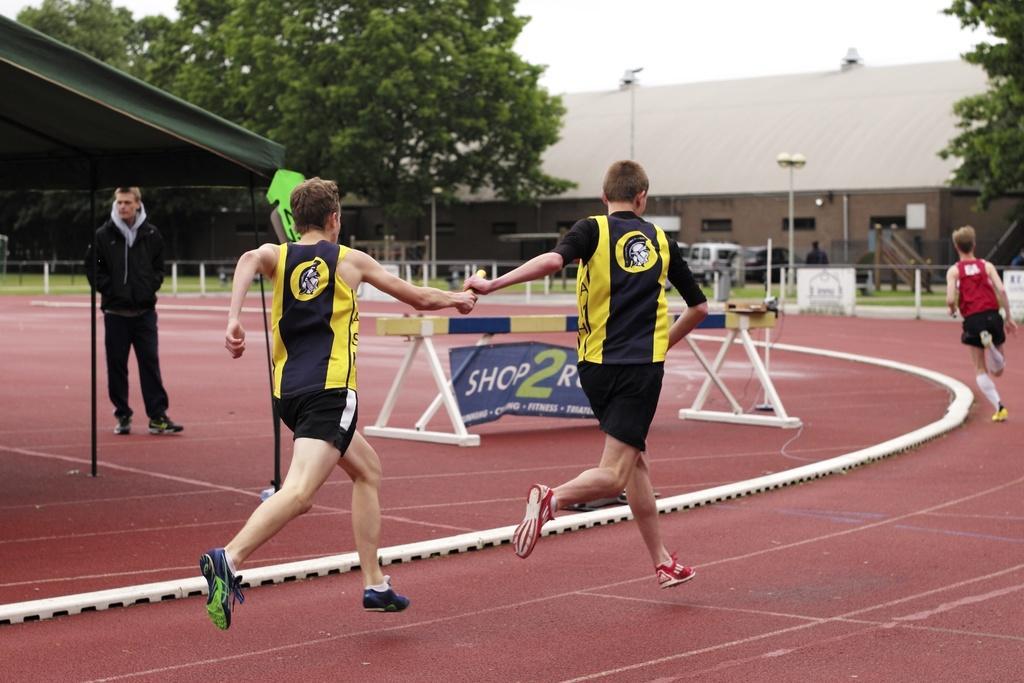Could you give a brief overview of what you see in this image? In this image we can see three people running on the running track. There are poles, trees. There is a person standing to the left side of the image. There is a tent. There is a banner with some text on it. At the top of the image there is sky. 